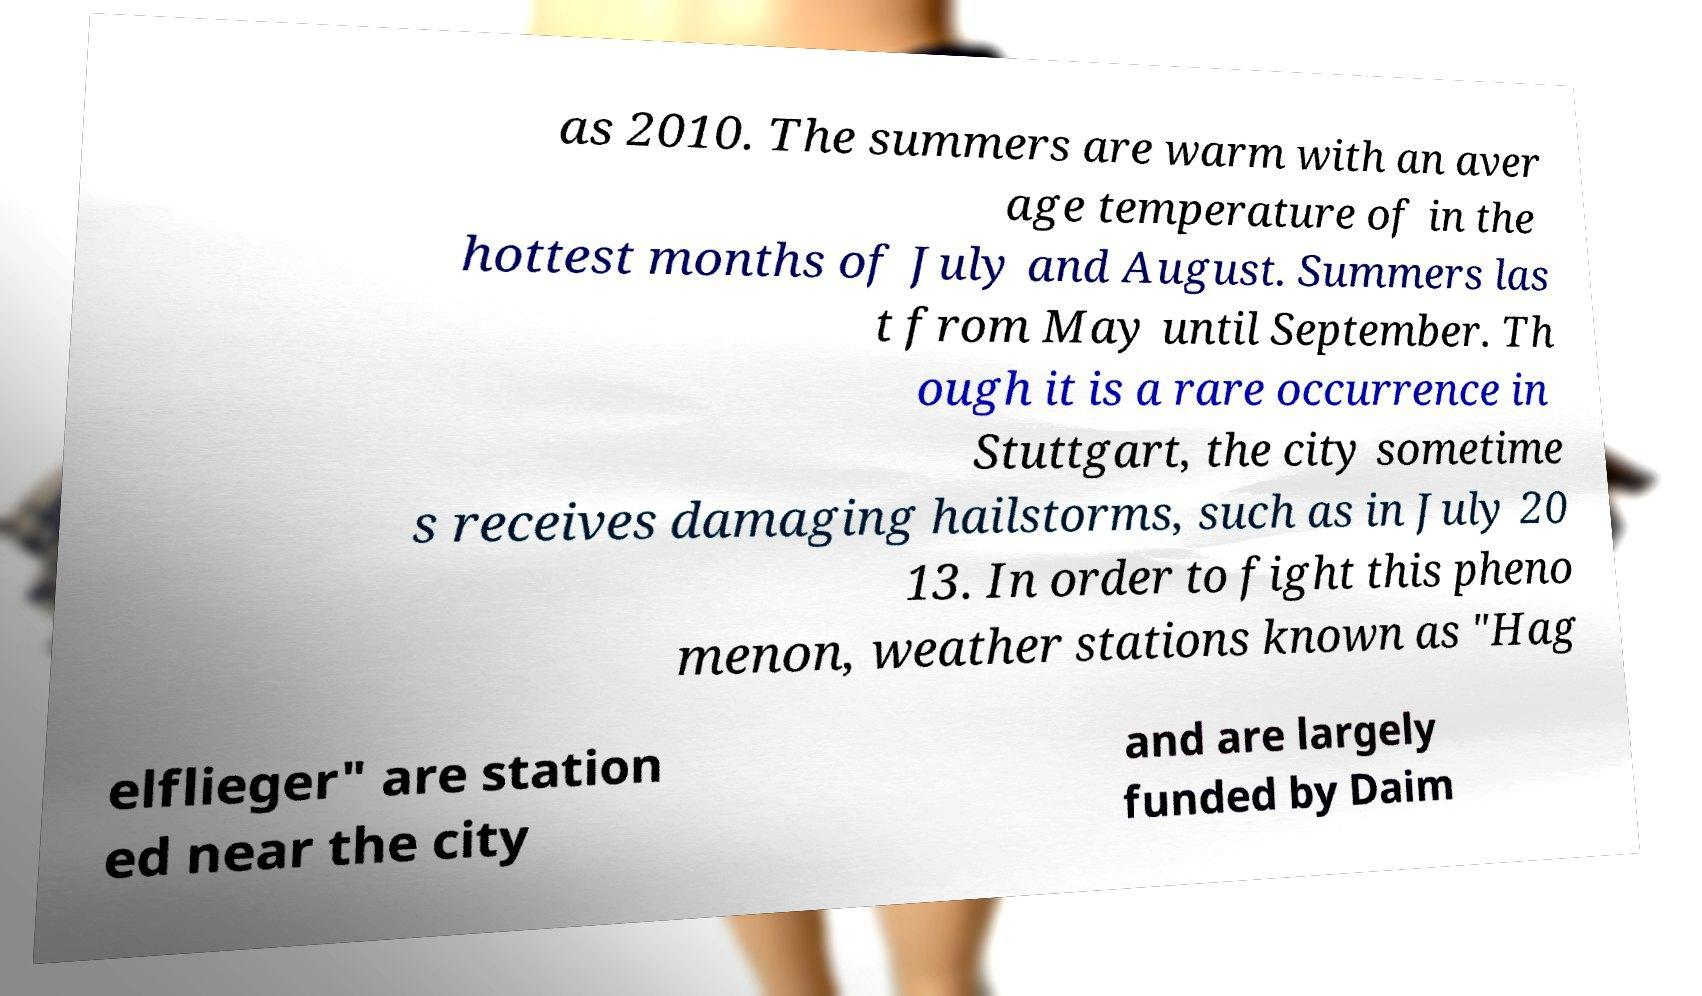Can you read and provide the text displayed in the image?This photo seems to have some interesting text. Can you extract and type it out for me? as 2010. The summers are warm with an aver age temperature of in the hottest months of July and August. Summers las t from May until September. Th ough it is a rare occurrence in Stuttgart, the city sometime s receives damaging hailstorms, such as in July 20 13. In order to fight this pheno menon, weather stations known as "Hag elflieger" are station ed near the city and are largely funded by Daim 